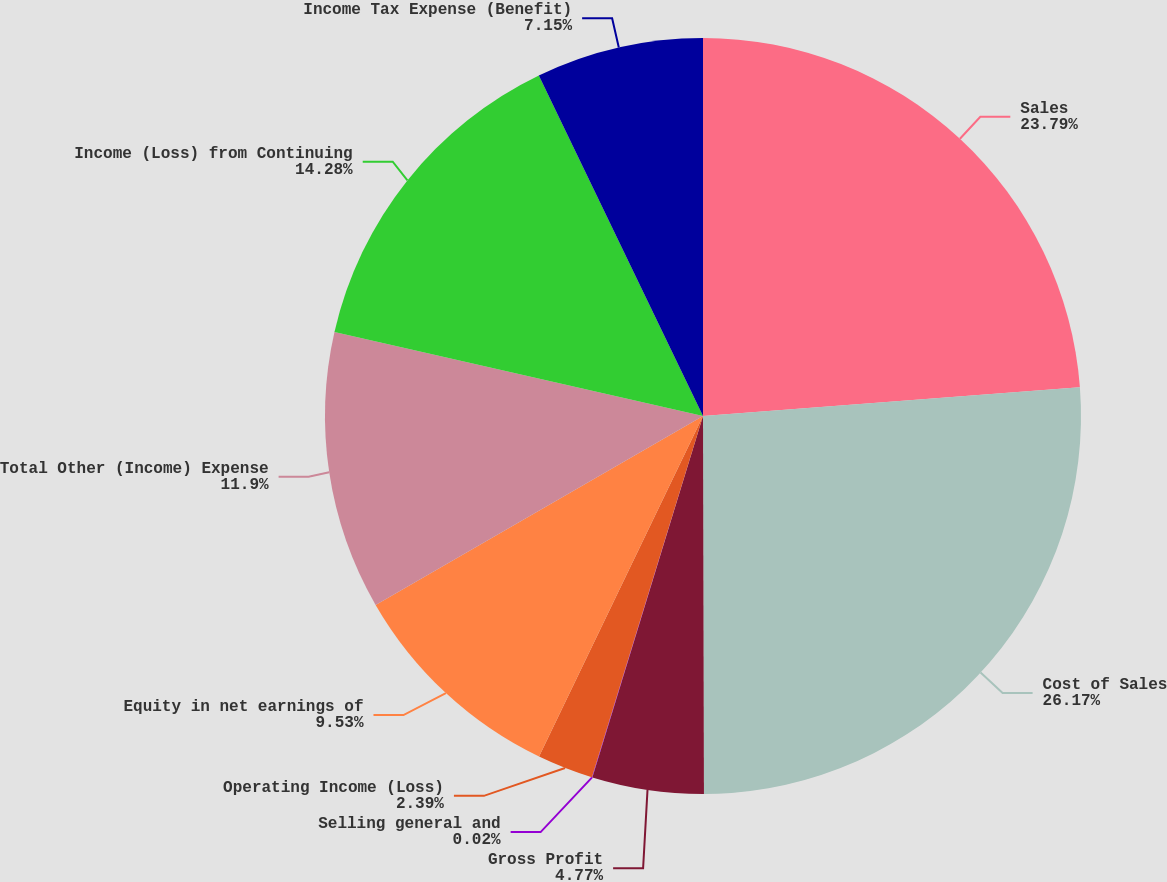Convert chart to OTSL. <chart><loc_0><loc_0><loc_500><loc_500><pie_chart><fcel>Sales<fcel>Cost of Sales<fcel>Gross Profit<fcel>Selling general and<fcel>Operating Income (Loss)<fcel>Equity in net earnings of<fcel>Total Other (Income) Expense<fcel>Income (Loss) from Continuing<fcel>Income Tax Expense (Benefit)<nl><fcel>23.79%<fcel>26.17%<fcel>4.77%<fcel>0.02%<fcel>2.39%<fcel>9.53%<fcel>11.9%<fcel>14.28%<fcel>7.15%<nl></chart> 